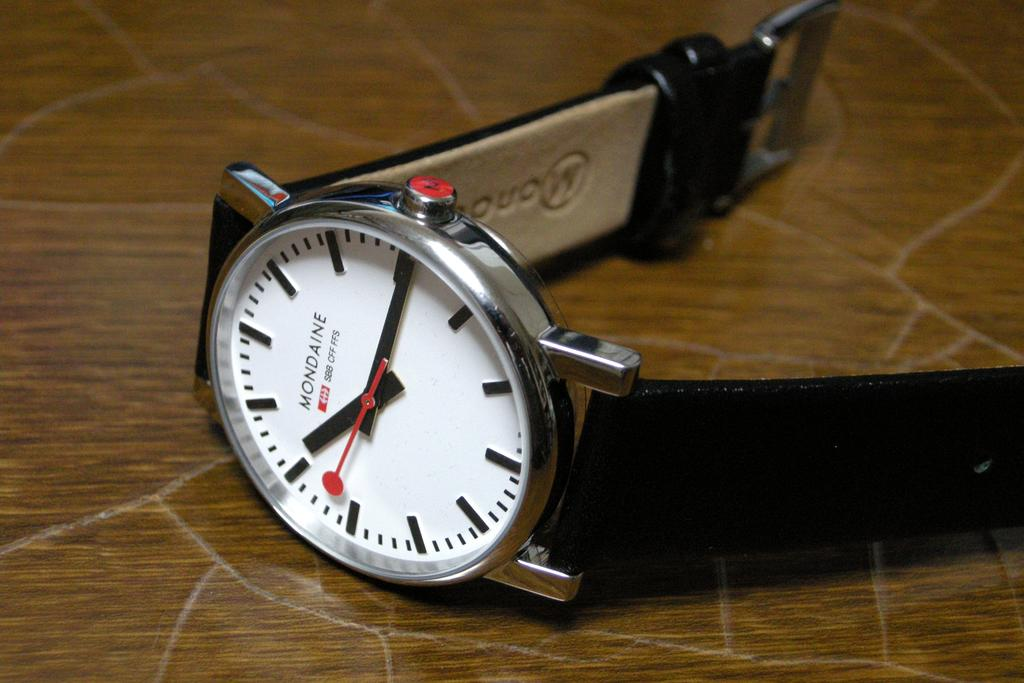<image>
Present a compact description of the photo's key features. A Mondaine brand watch is displayed on a wooden surface. 